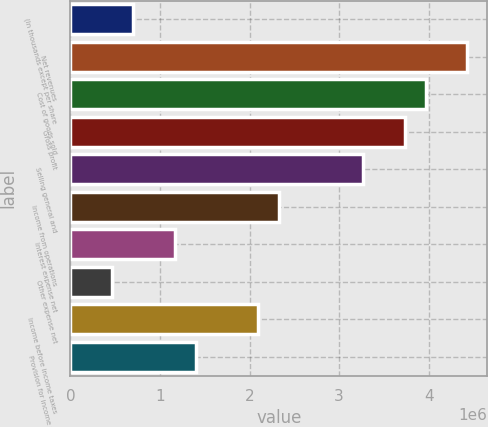Convert chart. <chart><loc_0><loc_0><loc_500><loc_500><bar_chart><fcel>(In thousands except per share<fcel>Net revenues<fcel>Cost of goods sold<fcel>Gross profit<fcel>Selling general and<fcel>Income from operations<fcel>Interest expense net<fcel>Other expense net<fcel>Income before income taxes<fcel>Provision for income taxes<nl><fcel>699616<fcel>4.4309e+06<fcel>3.96449e+06<fcel>3.73128e+06<fcel>3.26487e+06<fcel>2.33205e+06<fcel>1.16603e+06<fcel>466411<fcel>2.09885e+06<fcel>1.39923e+06<nl></chart> 